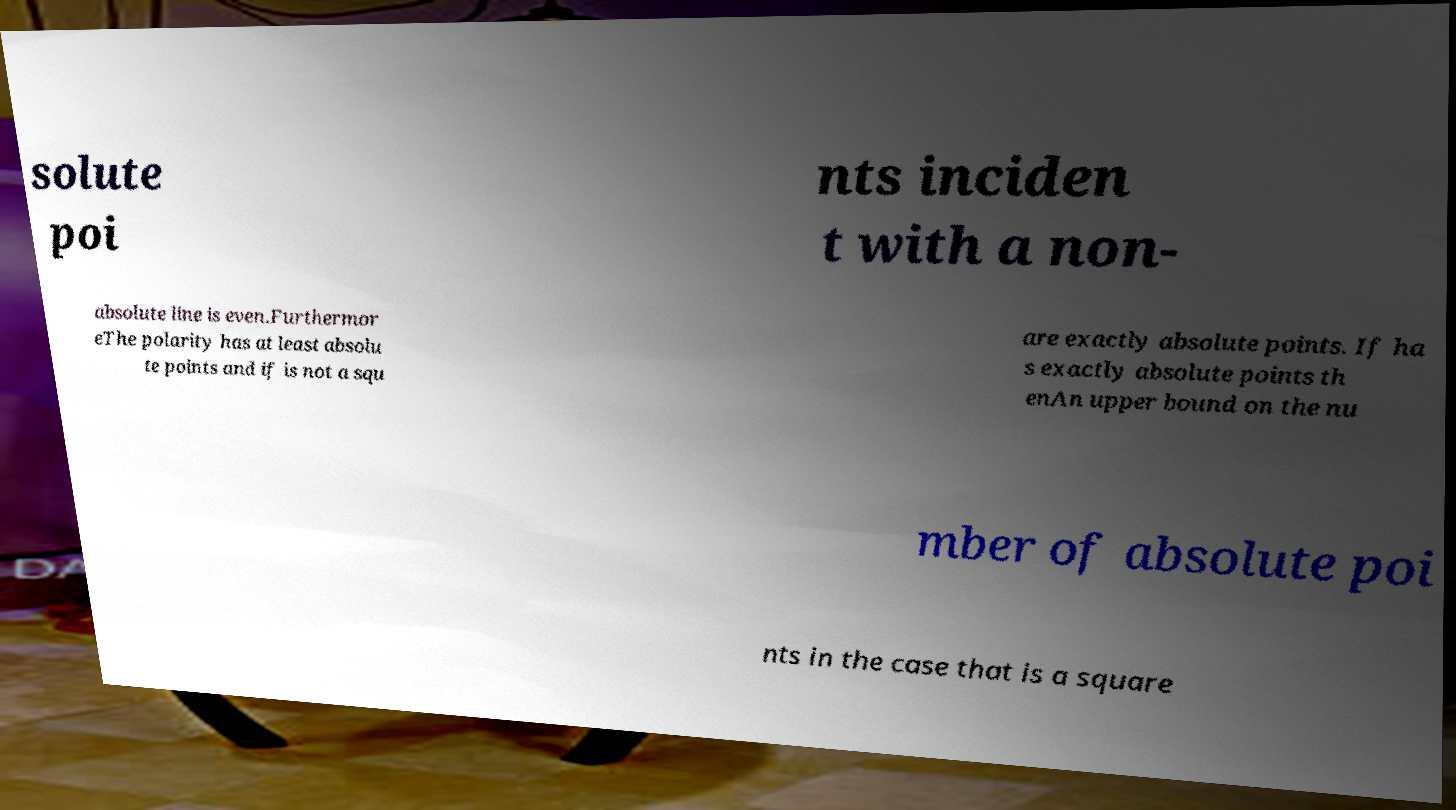Please identify and transcribe the text found in this image. solute poi nts inciden t with a non- absolute line is even.Furthermor eThe polarity has at least absolu te points and if is not a squ are exactly absolute points. If ha s exactly absolute points th enAn upper bound on the nu mber of absolute poi nts in the case that is a square 